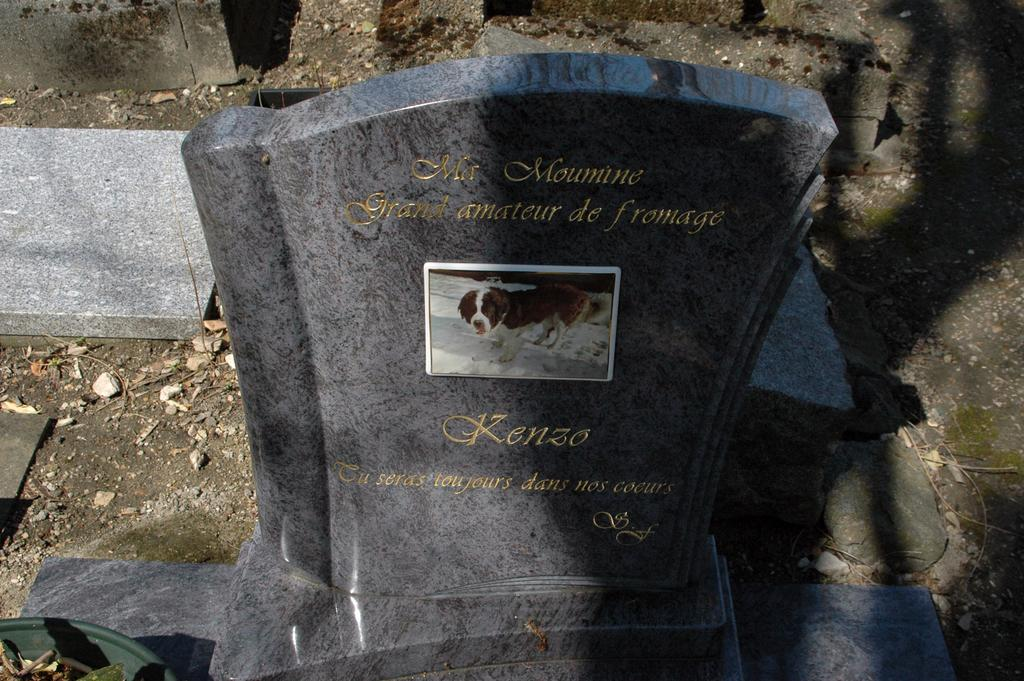What type of location is depicted in the image? There is a graveyard in the image. What can be found on the graveyard? There is text written on the graveyard. How many mittens are hanging on the fence in the image? There are no mittens present in the image; it features a graveyard with text. 